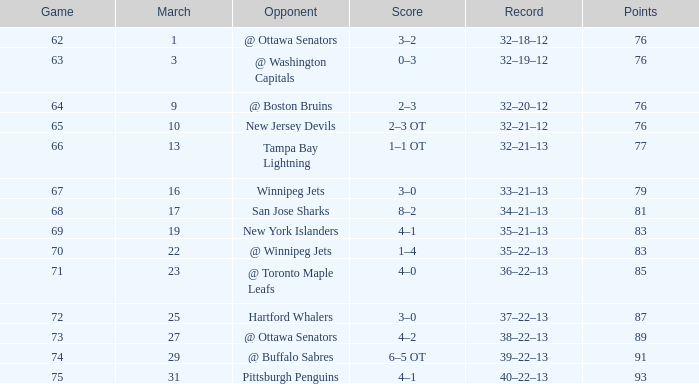What is the quantity of points for march if it amounts to 85 points? 1.0. Write the full table. {'header': ['Game', 'March', 'Opponent', 'Score', 'Record', 'Points'], 'rows': [['62', '1', '@ Ottawa Senators', '3–2', '32–18–12', '76'], ['63', '3', '@ Washington Capitals', '0–3', '32–19–12', '76'], ['64', '9', '@ Boston Bruins', '2–3', '32–20–12', '76'], ['65', '10', 'New Jersey Devils', '2–3 OT', '32–21–12', '76'], ['66', '13', 'Tampa Bay Lightning', '1–1 OT', '32–21–13', '77'], ['67', '16', 'Winnipeg Jets', '3–0', '33–21–13', '79'], ['68', '17', 'San Jose Sharks', '8–2', '34–21–13', '81'], ['69', '19', 'New York Islanders', '4–1', '35–21–13', '83'], ['70', '22', '@ Winnipeg Jets', '1–4', '35–22–13', '83'], ['71', '23', '@ Toronto Maple Leafs', '4–0', '36–22–13', '85'], ['72', '25', 'Hartford Whalers', '3–0', '37–22–13', '87'], ['73', '27', '@ Ottawa Senators', '4–2', '38–22–13', '89'], ['74', '29', '@ Buffalo Sabres', '6–5 OT', '39–22–13', '91'], ['75', '31', 'Pittsburgh Penguins', '4–1', '40–22–13', '93']]} 